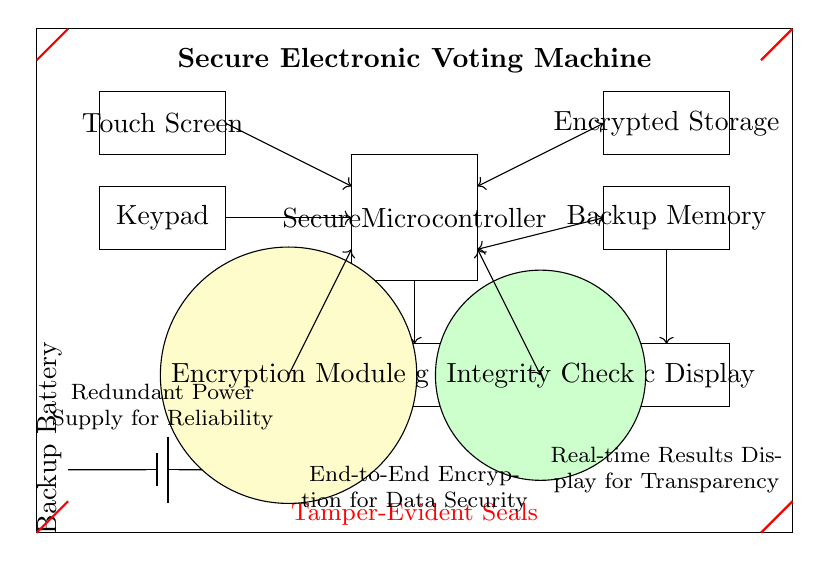What is the main processing unit in this circuit? The diagram identifies the processing unit as the "Secure Microcontroller," which is a key component responsible for the operation of the voting machine.
Answer: Secure Microcontroller How is the data stored in this circuit? The circuit shows two memory units labeled "Encrypted Storage" and "Backup Memory," indicating that data is stored securely and backed up in case of failures.
Answer: Encrypted Storage and Backup Memory What is the purpose of the red seals in the circuit? The red seals labeled "Tamper-Evident Seals" indicate a security feature designed to show whether the machine has been tampered with, ensuring the integrity of the voting process.
Answer: Tamper-Evident Seals What security feature connects the microcontroller and the data storage? The "Encryption Module" is drawn as a separate component and is shown to connect the Secure Microcontroller to the Encrypted Storage, indicating its role in securing the data.
Answer: Encryption Module How does the circuit ensure transparency in voting results? The "Audit Log Printer" and "Public Display" components are specifically designed to provide transparency by producing physical voting logs and displaying results publicly, ensuring the process can be audited.
Answer: Audit Log Printer and Public Display What type of power supply is included in this voting machine? The circuit features a "Backup Battery," which is essential for ensuring that the voting machine remains operational during power outages, thus increasing reliability.
Answer: Backup Battery 